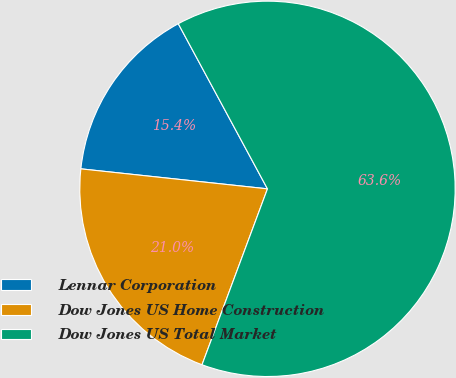Convert chart. <chart><loc_0><loc_0><loc_500><loc_500><pie_chart><fcel>Lennar Corporation<fcel>Dow Jones US Home Construction<fcel>Dow Jones US Total Market<nl><fcel>15.42%<fcel>21.03%<fcel>63.55%<nl></chart> 